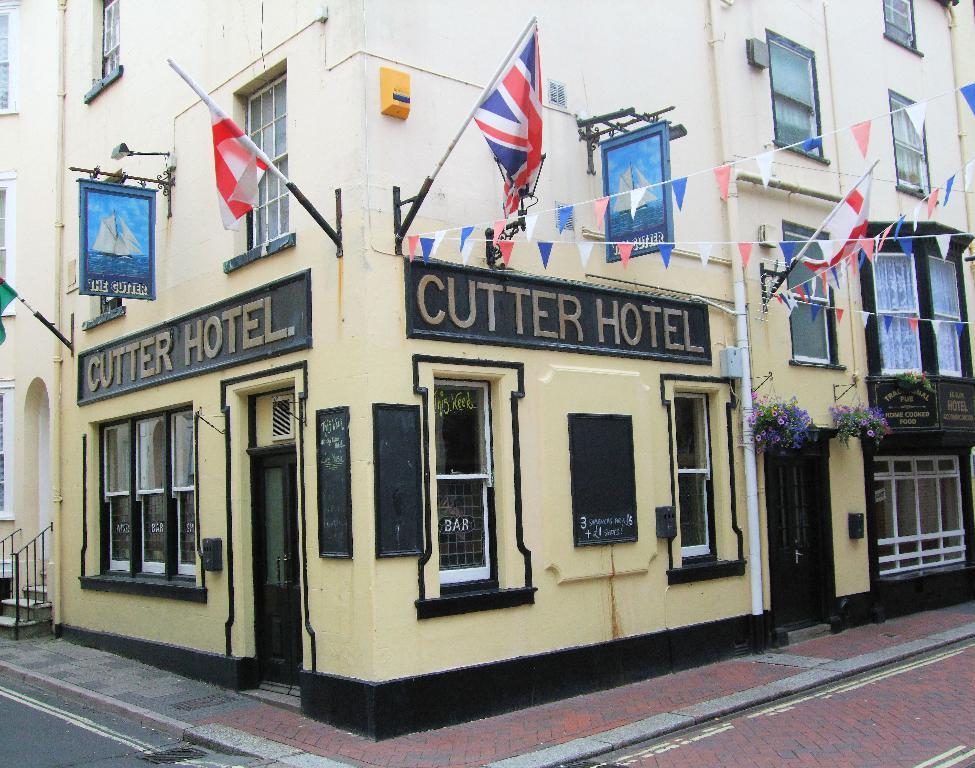Please provide a concise description of this image. This is a building. Here we can see boards, flags, hoardings, plants, and windows. 